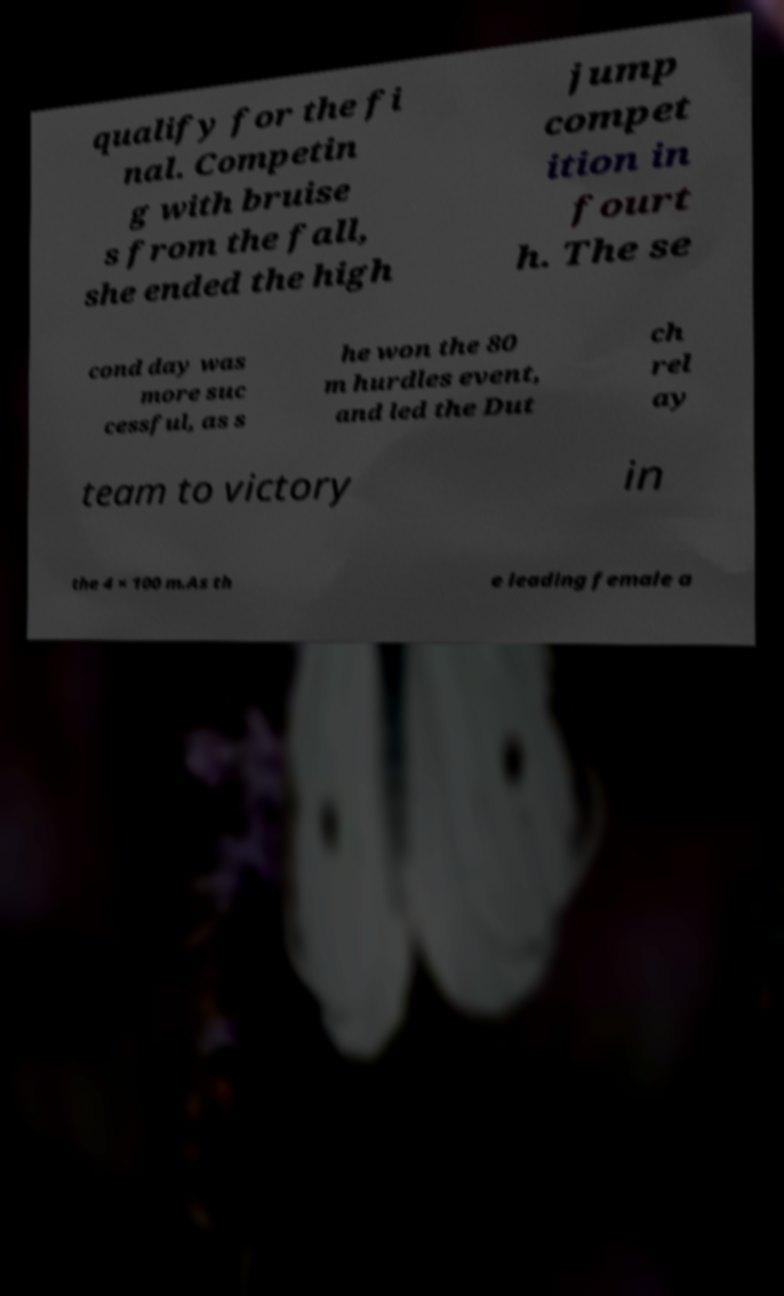Please read and relay the text visible in this image. What does it say? qualify for the fi nal. Competin g with bruise s from the fall, she ended the high jump compet ition in fourt h. The se cond day was more suc cessful, as s he won the 80 m hurdles event, and led the Dut ch rel ay team to victory in the 4 × 100 m.As th e leading female a 